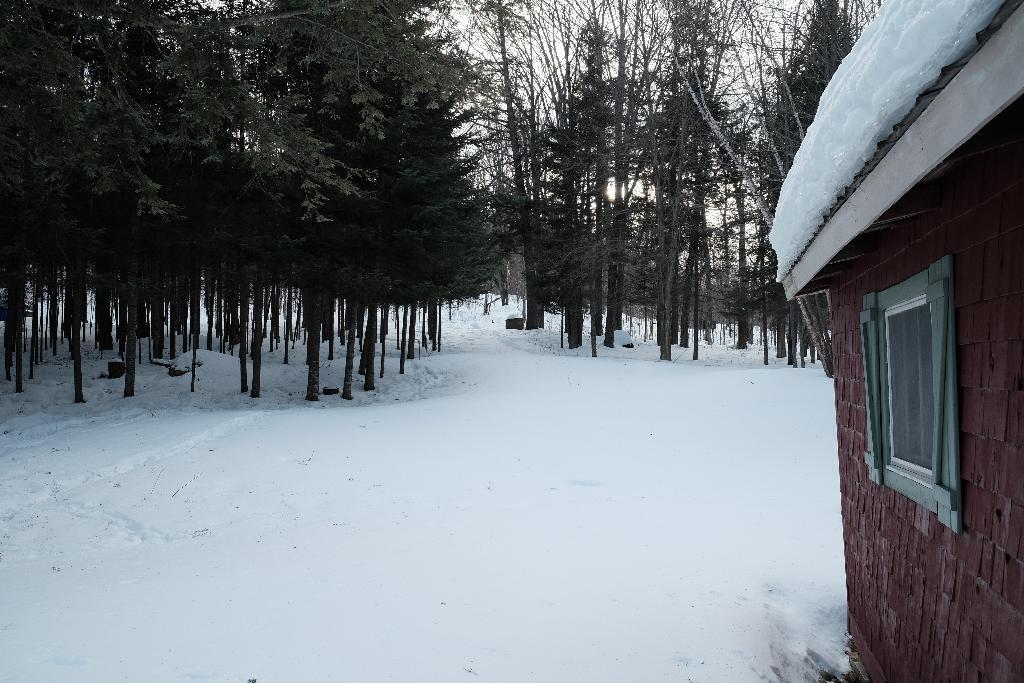In one or two sentences, can you explain what this image depicts? In the image we can see the snow, house and window. Here we can see trees and the sky.  